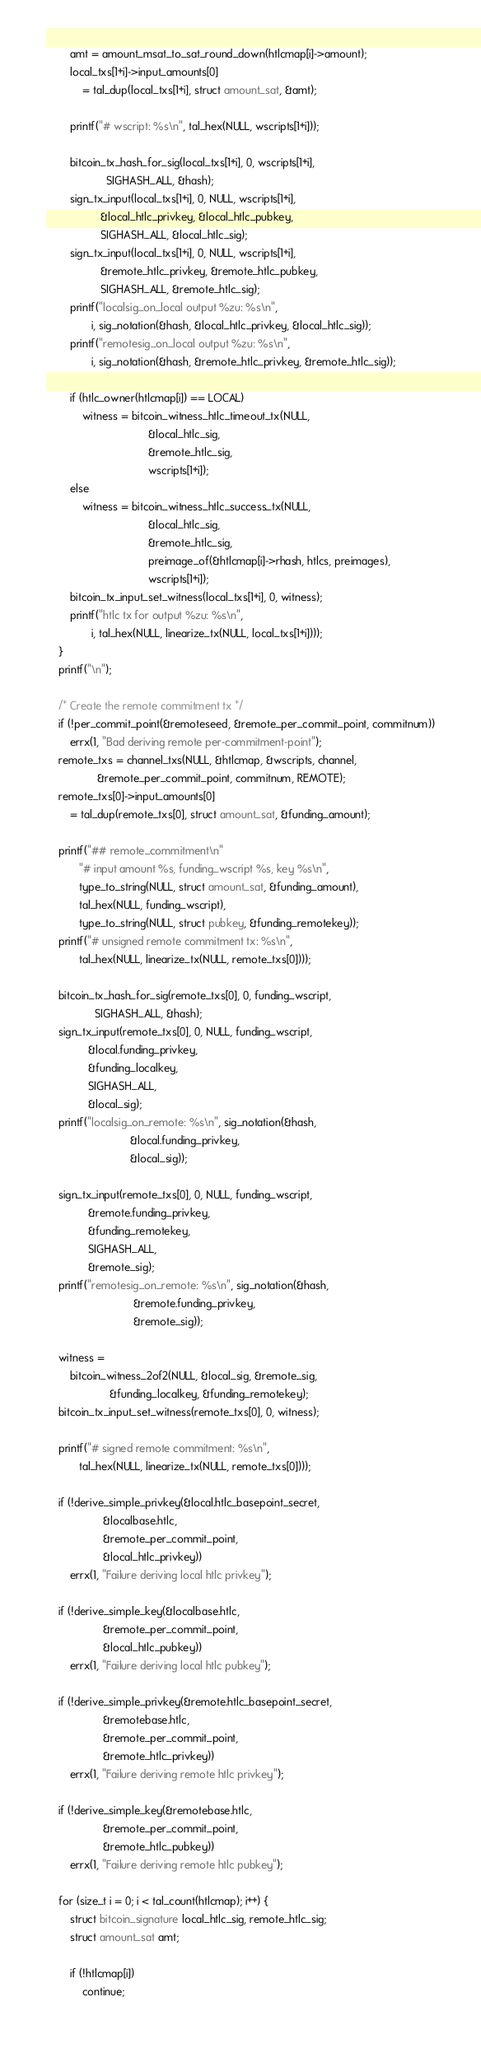Convert code to text. <code><loc_0><loc_0><loc_500><loc_500><_C_>		amt = amount_msat_to_sat_round_down(htlcmap[i]->amount);
		local_txs[1+i]->input_amounts[0]
			= tal_dup(local_txs[1+i], struct amount_sat, &amt);

		printf("# wscript: %s\n", tal_hex(NULL, wscripts[1+i]));

		bitcoin_tx_hash_for_sig(local_txs[1+i], 0, wscripts[1+i],
					SIGHASH_ALL, &hash);
		sign_tx_input(local_txs[1+i], 0, NULL, wscripts[1+i],
			      &local_htlc_privkey, &local_htlc_pubkey,
			      SIGHASH_ALL, &local_htlc_sig);
		sign_tx_input(local_txs[1+i], 0, NULL, wscripts[1+i],
			      &remote_htlc_privkey, &remote_htlc_pubkey,
			      SIGHASH_ALL, &remote_htlc_sig);
		printf("localsig_on_local output %zu: %s\n",
		       i, sig_notation(&hash, &local_htlc_privkey, &local_htlc_sig));
		printf("remotesig_on_local output %zu: %s\n",
		       i, sig_notation(&hash, &remote_htlc_privkey, &remote_htlc_sig));

		if (htlc_owner(htlcmap[i]) == LOCAL)
			witness = bitcoin_witness_htlc_timeout_tx(NULL,
								  &local_htlc_sig,
								  &remote_htlc_sig,
								  wscripts[1+i]);
		else
			witness = bitcoin_witness_htlc_success_tx(NULL,
								  &local_htlc_sig,
								  &remote_htlc_sig,
								  preimage_of(&htlcmap[i]->rhash, htlcs, preimages),
								  wscripts[1+i]);
		bitcoin_tx_input_set_witness(local_txs[1+i], 0, witness);
		printf("htlc tx for output %zu: %s\n",
		       i, tal_hex(NULL, linearize_tx(NULL, local_txs[1+i])));
	}
	printf("\n");

	/* Create the remote commitment tx */
	if (!per_commit_point(&remoteseed, &remote_per_commit_point, commitnum))
		errx(1, "Bad deriving remote per-commitment-point");
	remote_txs = channel_txs(NULL, &htlcmap, &wscripts, channel,
				 &remote_per_commit_point, commitnum, REMOTE);
	remote_txs[0]->input_amounts[0]
		= tal_dup(remote_txs[0], struct amount_sat, &funding_amount);

	printf("## remote_commitment\n"
	       "# input amount %s, funding_wscript %s, key %s\n",
	       type_to_string(NULL, struct amount_sat, &funding_amount),
	       tal_hex(NULL, funding_wscript),
	       type_to_string(NULL, struct pubkey, &funding_remotekey));
	printf("# unsigned remote commitment tx: %s\n",
	       tal_hex(NULL, linearize_tx(NULL, remote_txs[0])));

	bitcoin_tx_hash_for_sig(remote_txs[0], 0, funding_wscript,
				SIGHASH_ALL, &hash);
	sign_tx_input(remote_txs[0], 0, NULL, funding_wscript,
		      &local.funding_privkey,
		      &funding_localkey,
		      SIGHASH_ALL,
		      &local_sig);
	printf("localsig_on_remote: %s\n", sig_notation(&hash,
							&local.funding_privkey,
							&local_sig));

	sign_tx_input(remote_txs[0], 0, NULL, funding_wscript,
		      &remote.funding_privkey,
		      &funding_remotekey,
		      SIGHASH_ALL,
		      &remote_sig);
	printf("remotesig_on_remote: %s\n", sig_notation(&hash,
							 &remote.funding_privkey,
							 &remote_sig));

	witness =
		bitcoin_witness_2of2(NULL, &local_sig, &remote_sig,
				     &funding_localkey, &funding_remotekey);
	bitcoin_tx_input_set_witness(remote_txs[0], 0, witness);

	printf("# signed remote commitment: %s\n",
	       tal_hex(NULL, linearize_tx(NULL, remote_txs[0])));

	if (!derive_simple_privkey(&local.htlc_basepoint_secret,
				   &localbase.htlc,
				   &remote_per_commit_point,
				   &local_htlc_privkey))
		errx(1, "Failure deriving local htlc privkey");

	if (!derive_simple_key(&localbase.htlc,
			       &remote_per_commit_point,
			       &local_htlc_pubkey))
		errx(1, "Failure deriving local htlc pubkey");

	if (!derive_simple_privkey(&remote.htlc_basepoint_secret,
				   &remotebase.htlc,
				   &remote_per_commit_point,
				   &remote_htlc_privkey))
		errx(1, "Failure deriving remote htlc privkey");

	if (!derive_simple_key(&remotebase.htlc,
			       &remote_per_commit_point,
			       &remote_htlc_pubkey))
		errx(1, "Failure deriving remote htlc pubkey");

	for (size_t i = 0; i < tal_count(htlcmap); i++) {
		struct bitcoin_signature local_htlc_sig, remote_htlc_sig;
		struct amount_sat amt;

		if (!htlcmap[i])
			continue;</code> 